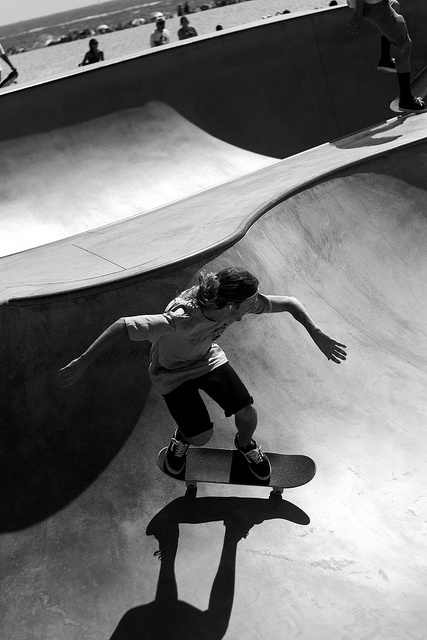Describe the objects in this image and their specific colors. I can see people in lightgray, black, gray, and darkgray tones, skateboard in lightgray, black, gray, and darkgray tones, people in lightgray, black, gray, and darkgray tones, people in lightgray, gray, black, and darkgray tones, and people in black, gray, darkgray, and lightgray tones in this image. 